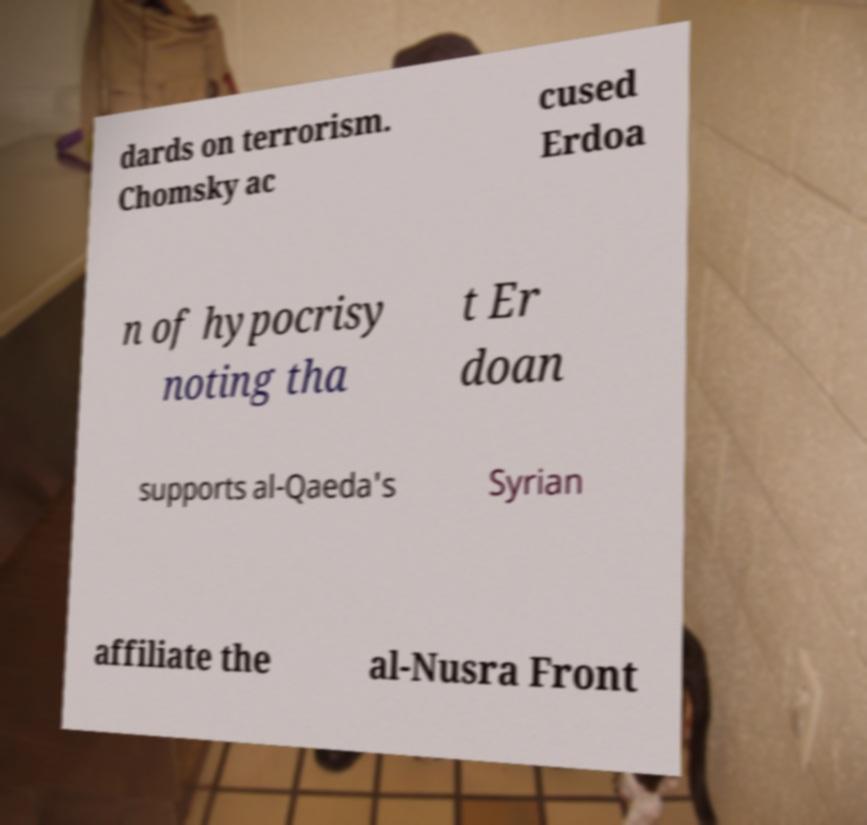Please identify and transcribe the text found in this image. dards on terrorism. Chomsky ac cused Erdoa n of hypocrisy noting tha t Er doan supports al-Qaeda's Syrian affiliate the al-Nusra Front 